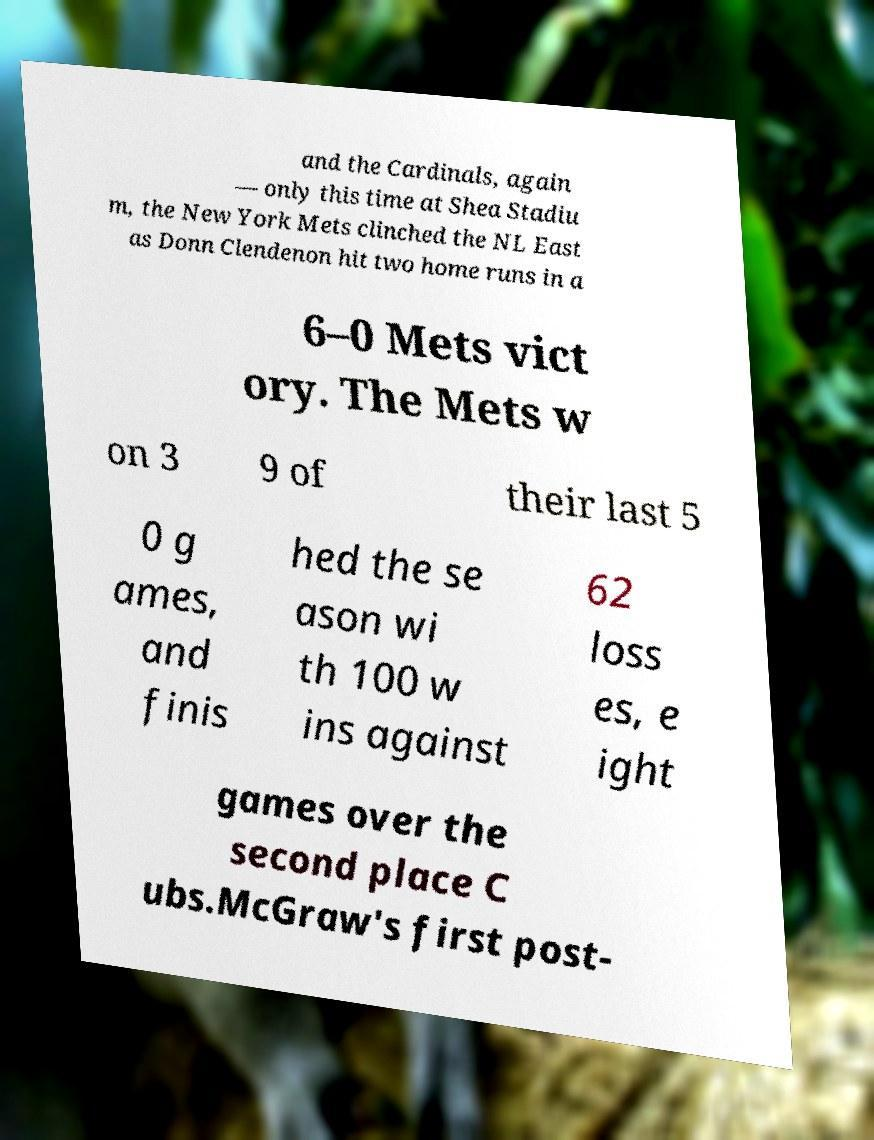What messages or text are displayed in this image? I need them in a readable, typed format. and the Cardinals, again — only this time at Shea Stadiu m, the New York Mets clinched the NL East as Donn Clendenon hit two home runs in a 6–0 Mets vict ory. The Mets w on 3 9 of their last 5 0 g ames, and finis hed the se ason wi th 100 w ins against 62 loss es, e ight games over the second place C ubs.McGraw's first post- 